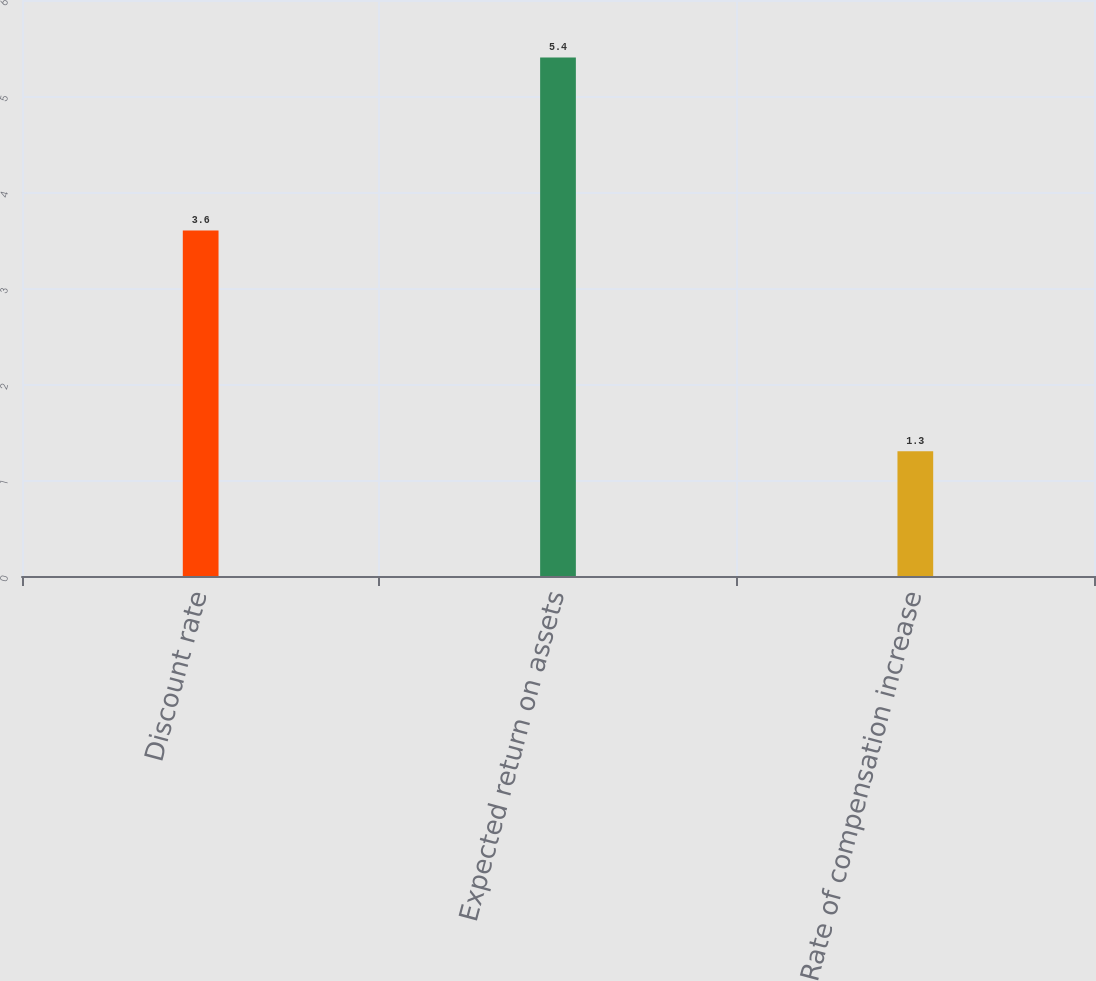Convert chart. <chart><loc_0><loc_0><loc_500><loc_500><bar_chart><fcel>Discount rate<fcel>Expected return on assets<fcel>Rate of compensation increase<nl><fcel>3.6<fcel>5.4<fcel>1.3<nl></chart> 